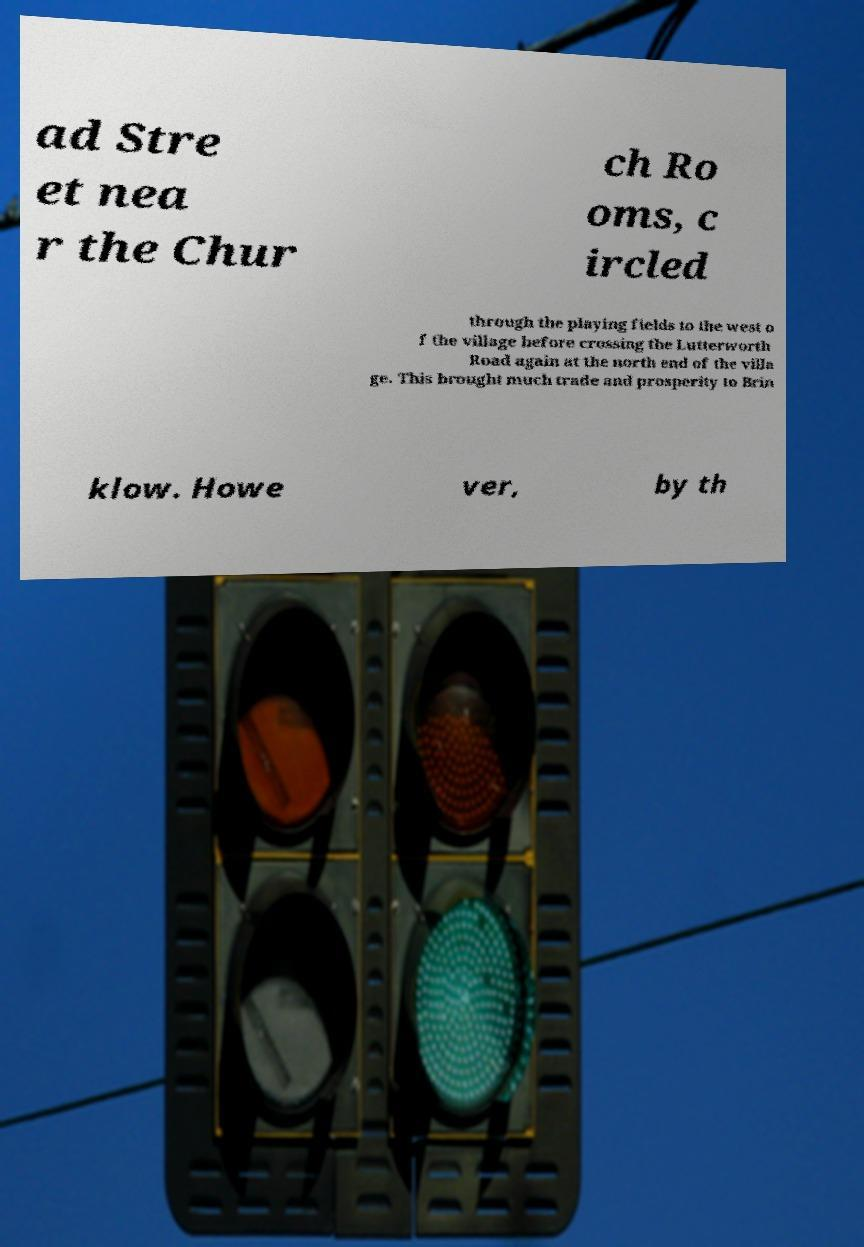Can you read and provide the text displayed in the image?This photo seems to have some interesting text. Can you extract and type it out for me? ad Stre et nea r the Chur ch Ro oms, c ircled through the playing fields to the west o f the village before crossing the Lutterworth Road again at the north end of the villa ge. This brought much trade and prosperity to Brin klow. Howe ver, by th 